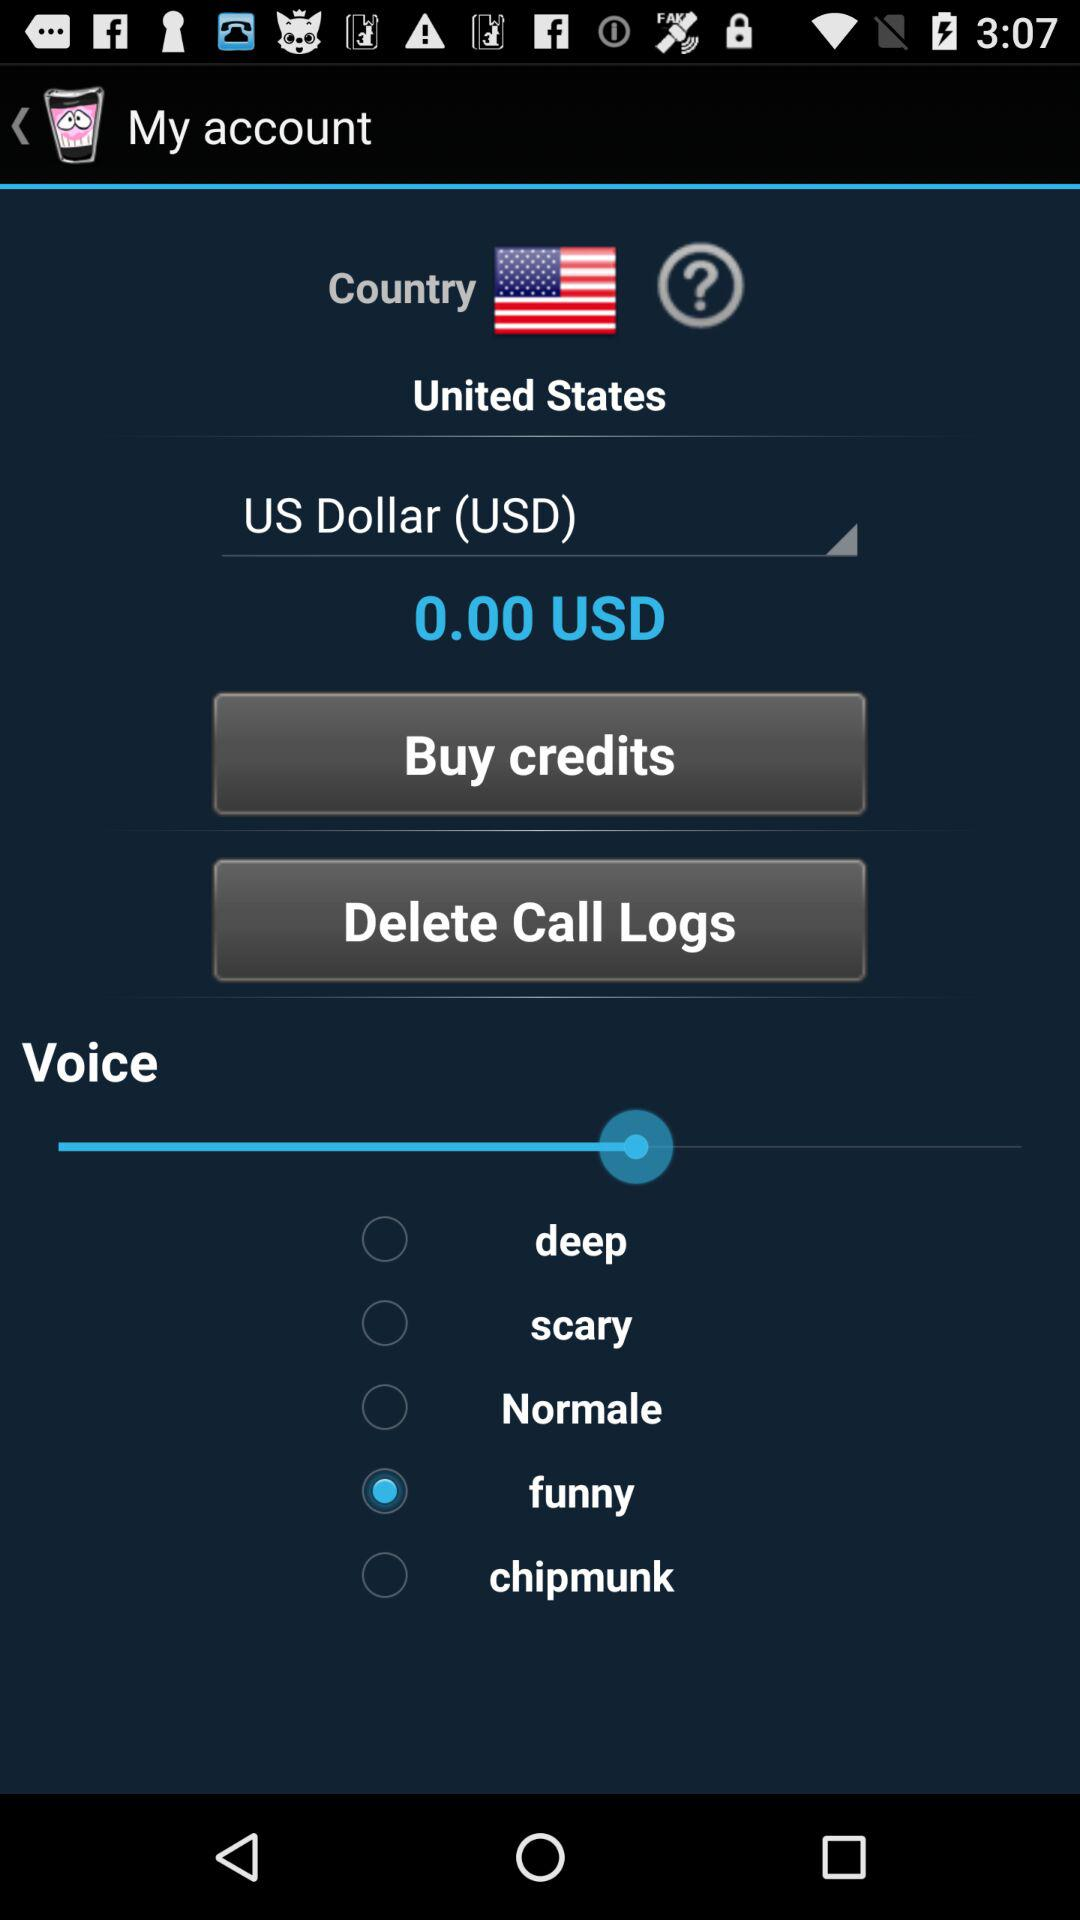What is the selected currency? The selected currency is "US Dollar (USD)". 